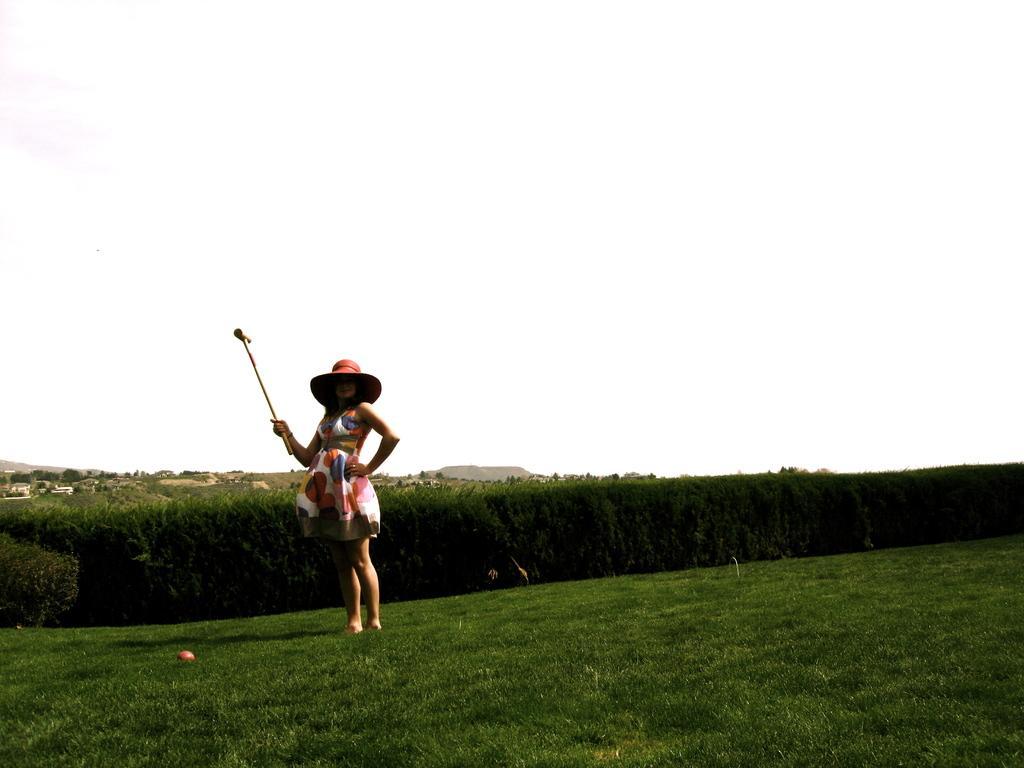Please provide a concise description of this image. In this picture I can see the grass and I see a woman who is standing and I see that she is wearing a hat and she is holding a thing. In the middle of this picture I can see the bushes. In the background I can see the sky. 